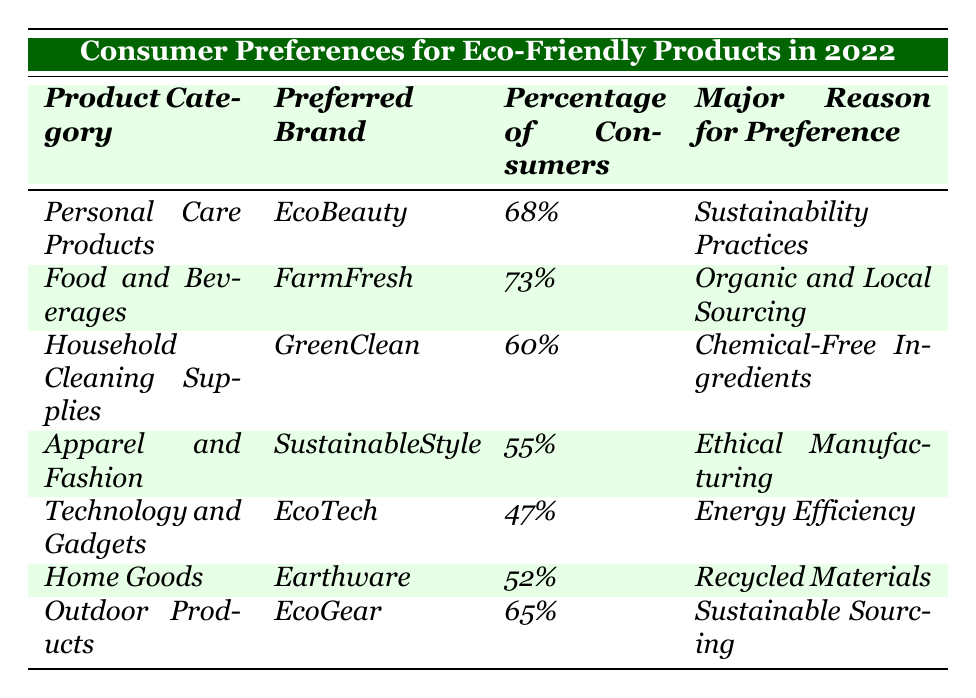What is the preferred brand for Food and Beverages? The table lists "FarmFresh" as the preferred brand under the product category "Food and Beverages."
Answer: FarmFresh Which product category has the highest percentage of consumers? The highest percentage is in the "Food and Beverages" category at 73%.
Answer: Food and Beverages What is the major reason for preference for Personal Care Products? According to the table, the major reason for preference for Personal Care Products is "Sustainability Practices."
Answer: Sustainability Practices Is the percentage of consumers preferring Technology and Gadgets greater than 50%? The percentage of consumers for Technology and Gadgets is 47%, which is less than 50%.
Answer: No Calculate the average percentage of consumers for the product categories listed. The percentages are 68%, 73%, 60%, 55%, 47%, 52%, and 65%. Adding them gives a total of 400%. There are 7 categories, so the average is 400% / 7 = 57.14%.
Answer: 57.14% Which product category has the lowest percentage of consumers, and what is that percentage? The lowest percentage is for Technology and Gadgets at 47%.
Answer: Technology and Gadgets, 47% Does apparel and fashion have a higher percentage of consumers compared to household cleaning supplies? Apparel and Fashion has 55% while Household Cleaning Supplies has 60%, which means Apparel and Fashion has a lower percentage.
Answer: No What is the major reason for preference for Outdoor Products, and how does it compare to the preference for Technology and Gadgets? The major reason for preference for Outdoor Products is "Sustainable Sourcing," while for Technology and Gadgets, it is "Energy Efficiency." Both categories have reasons related to sustainability, but Outdoor Products' percentage of consumers is higher (65% vs 47%).
Answer: Sustainable Sourcing; higher percentage for Outdoor Products List the product categories in order of consumer preference from highest to lowest percentage. The order from highest to lowest based on percentage is: Food and Beverages, Personal Care Products, Outdoor Products, Household Cleaning Supplies, Home Goods, Apparel and Fashion, Technology and Gadgets.
Answer: Food and Beverages, Personal Care Products, Outdoor Products, Household Cleaning Supplies, Home Goods, Apparel and Fashion, Technology and Gadgets What is the total combined percentage of consumers for the product categories with over 60% preference? The categories with over 60% are Food and Beverages (73%), Personal Care Products (68%), Outdoor Products (65%). Their combined percentage is 73% + 68% + 65% = 206%.
Answer: 206% 